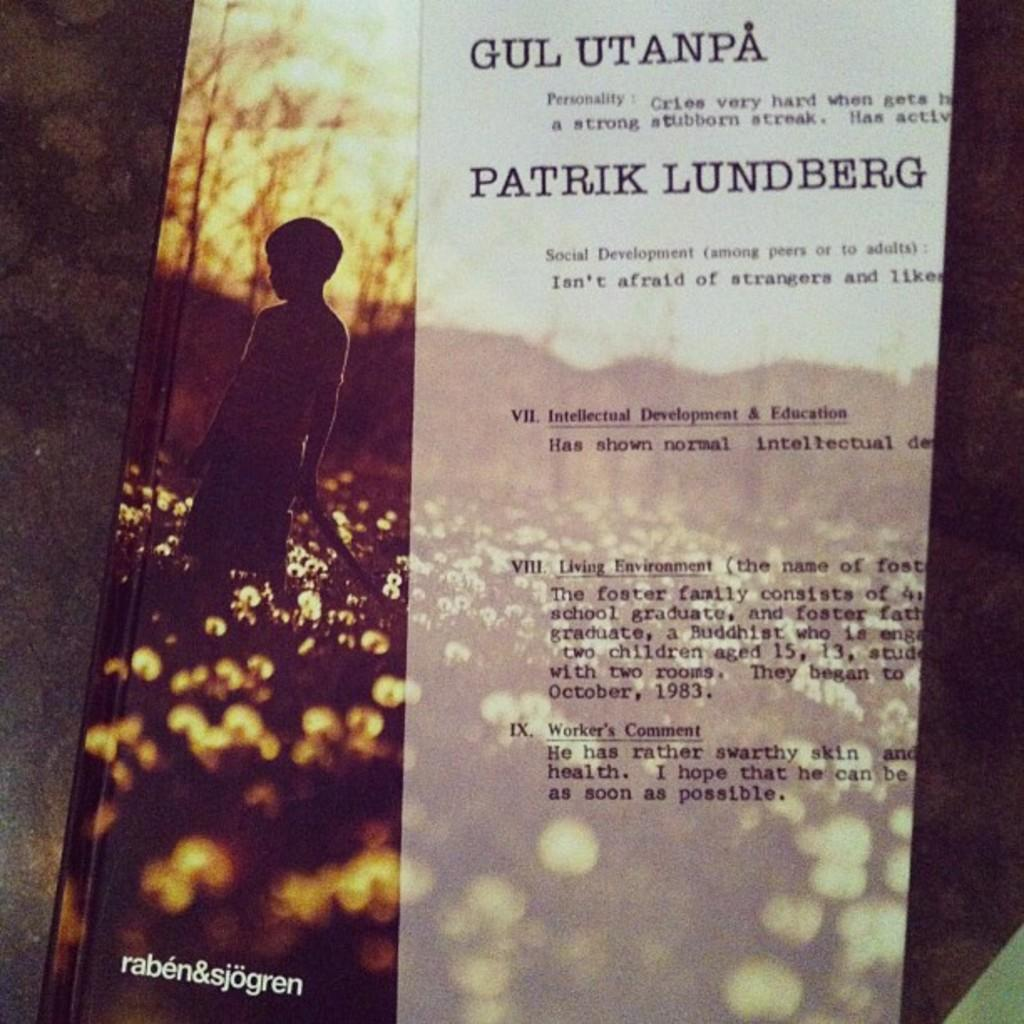<image>
Offer a succinct explanation of the picture presented. Cover of a book showing a boy in a field and the words "raben&sjogren" on the bottom. 